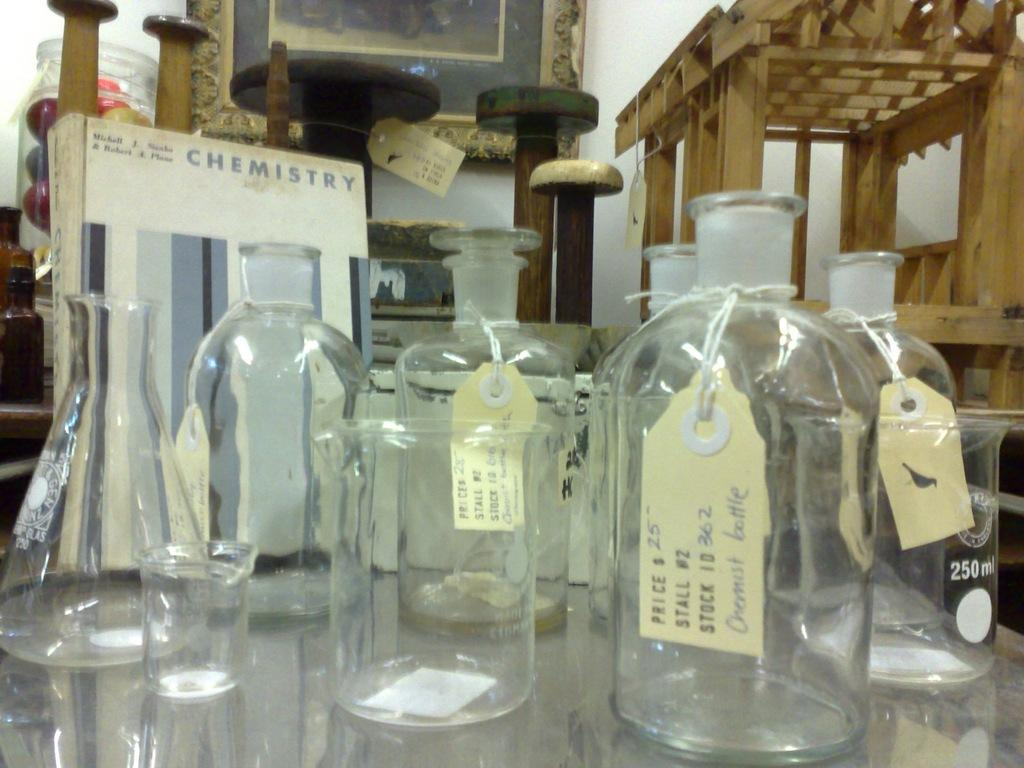<image>
Relay a brief, clear account of the picture shown. Glass containers with paper tags displayed in front of a Chemistry book. 